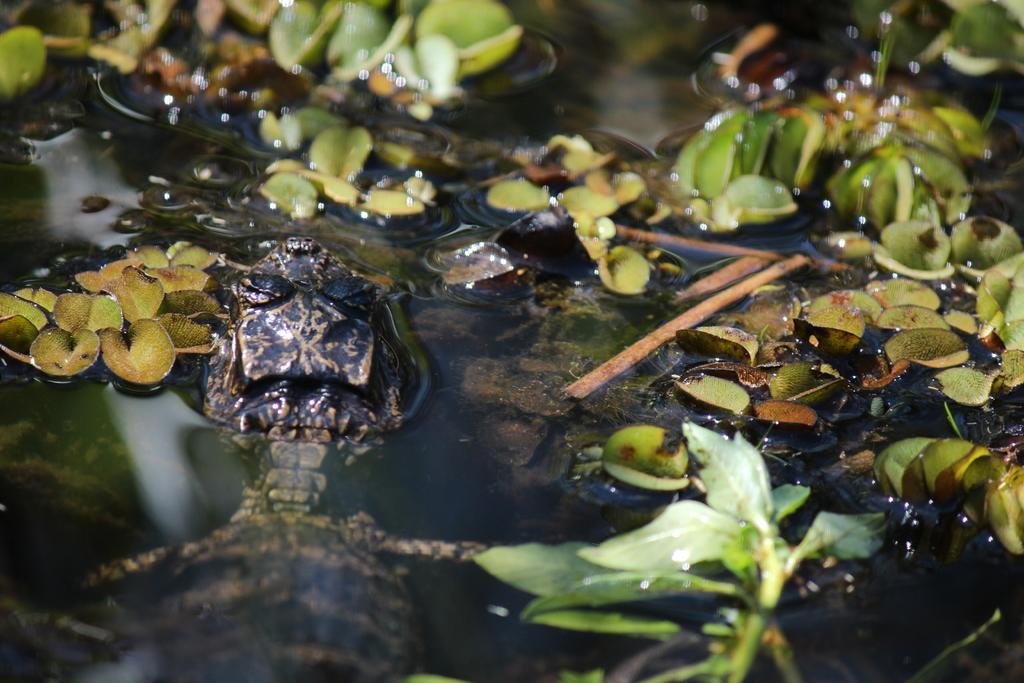What is the primary element visible in the image? There is water in the image. What can be seen floating on the water? There are green-colored leaves on the water. What objects are present on the left side of the image? There are black-colored objects on the left side of the image. How many dogs are wearing stockings in the image? There are no dogs or stockings present in the image. What type of cushion is visible on the water? There is no cushion visible in the image; it features water with green-colored leaves and black-colored objects on the left side. 